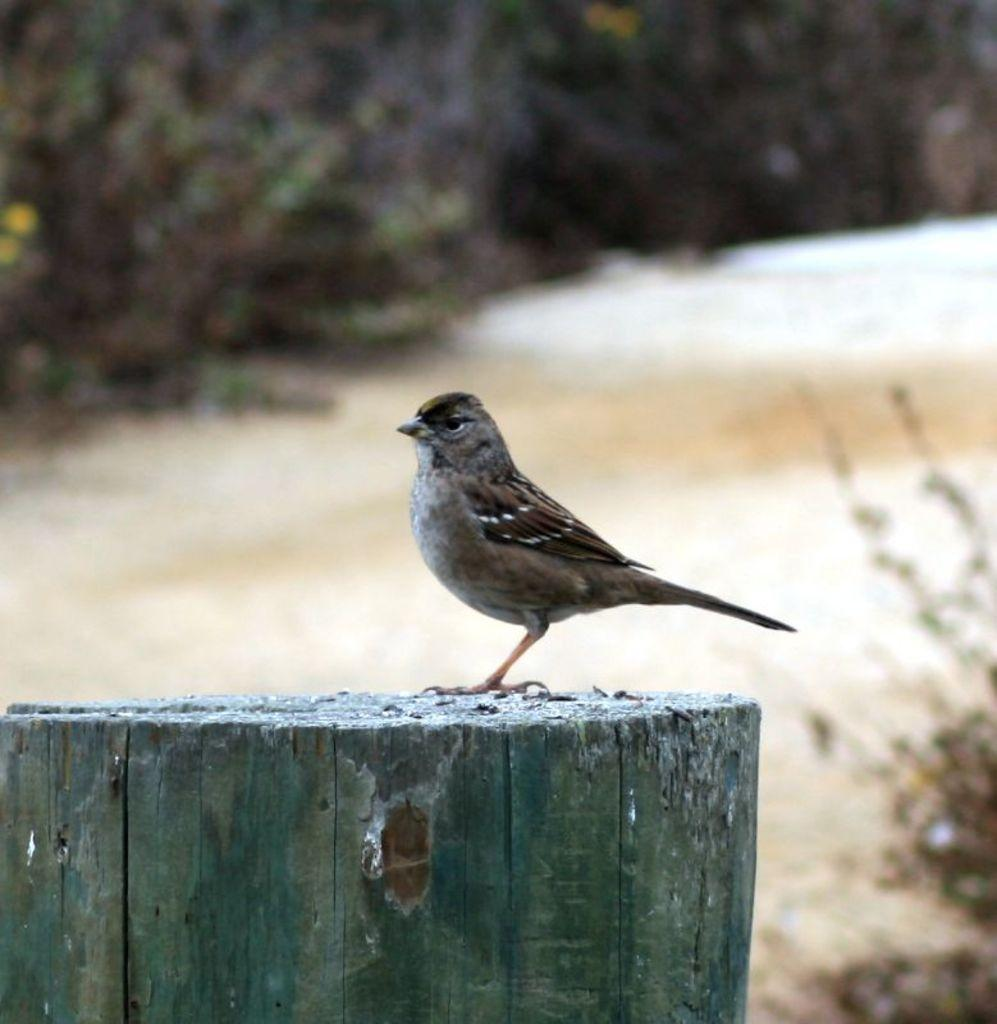What type of animal is in the image? There is a bird in the image. Where is the bird located? The bird is on a wooden log. What can be seen in the background of the image? There are trees in the background of the image. What is the bird's tendency to chew on the cork in the image? There is no cork present in the image, so it is not possible to determine the bird's tendency to chew on it. 